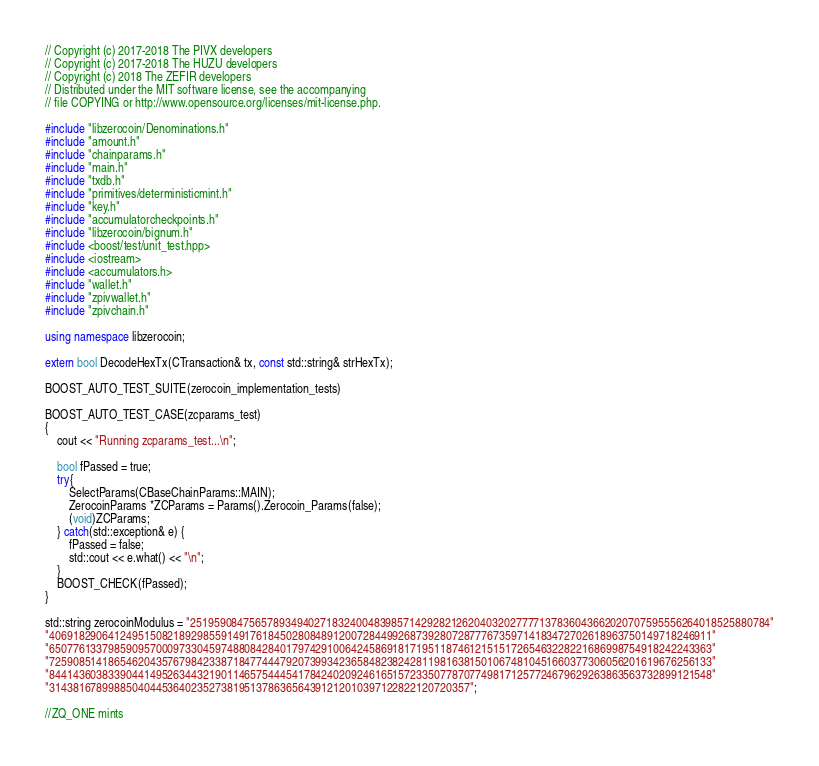Convert code to text. <code><loc_0><loc_0><loc_500><loc_500><_C++_>// Copyright (c) 2017-2018 The PIVX developers
// Copyright (c) 2017-2018 The HUZU developers
// Copyright (c) 2018 The ZEFIR developers
// Distributed under the MIT software license, see the accompanying
// file COPYING or http://www.opensource.org/licenses/mit-license.php.

#include "libzerocoin/Denominations.h"
#include "amount.h"
#include "chainparams.h"
#include "main.h"
#include "txdb.h"
#include "primitives/deterministicmint.h"
#include "key.h"
#include "accumulatorcheckpoints.h"
#include "libzerocoin/bignum.h"
#include <boost/test/unit_test.hpp>
#include <iostream>
#include <accumulators.h>
#include "wallet.h"
#include "zpivwallet.h"
#include "zpivchain.h"

using namespace libzerocoin;

extern bool DecodeHexTx(CTransaction& tx, const std::string& strHexTx);

BOOST_AUTO_TEST_SUITE(zerocoin_implementation_tests)

BOOST_AUTO_TEST_CASE(zcparams_test)
{
    cout << "Running zcparams_test...\n";

    bool fPassed = true;
    try{
        SelectParams(CBaseChainParams::MAIN);
        ZerocoinParams *ZCParams = Params().Zerocoin_Params(false);
        (void)ZCParams;
    } catch(std::exception& e) {
        fPassed = false;
        std::cout << e.what() << "\n";
    }
    BOOST_CHECK(fPassed);
}

std::string zerocoinModulus = "25195908475657893494027183240048398571429282126204032027777137836043662020707595556264018525880784"
"4069182906412495150821892985591491761845028084891200728449926873928072877767359714183472702618963750149718246911"
"6507761337985909570009733045974880842840179742910064245869181719511874612151517265463228221686998754918242243363"
"7259085141865462043576798423387184774447920739934236584823824281198163815010674810451660377306056201619676256133"
"8441436038339044149526344321901146575444541784240209246165157233507787077498171257724679629263863563732899121548"
"31438167899885040445364023527381951378636564391212010397122822120720357";

//ZQ_ONE mints</code> 